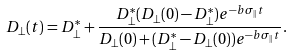Convert formula to latex. <formula><loc_0><loc_0><loc_500><loc_500>D _ { \perp } ( t ) = D _ { \perp } ^ { * } + \frac { D _ { \perp } ^ { * } ( D _ { \perp } ( 0 ) - D _ { \perp } ^ { * } ) e ^ { - b \sigma _ { \| } t } } { D _ { \perp } ( 0 ) + ( D _ { \perp } ^ { * } - D _ { \perp } ( 0 ) ) e ^ { - b \sigma _ { \| } t } } .</formula> 